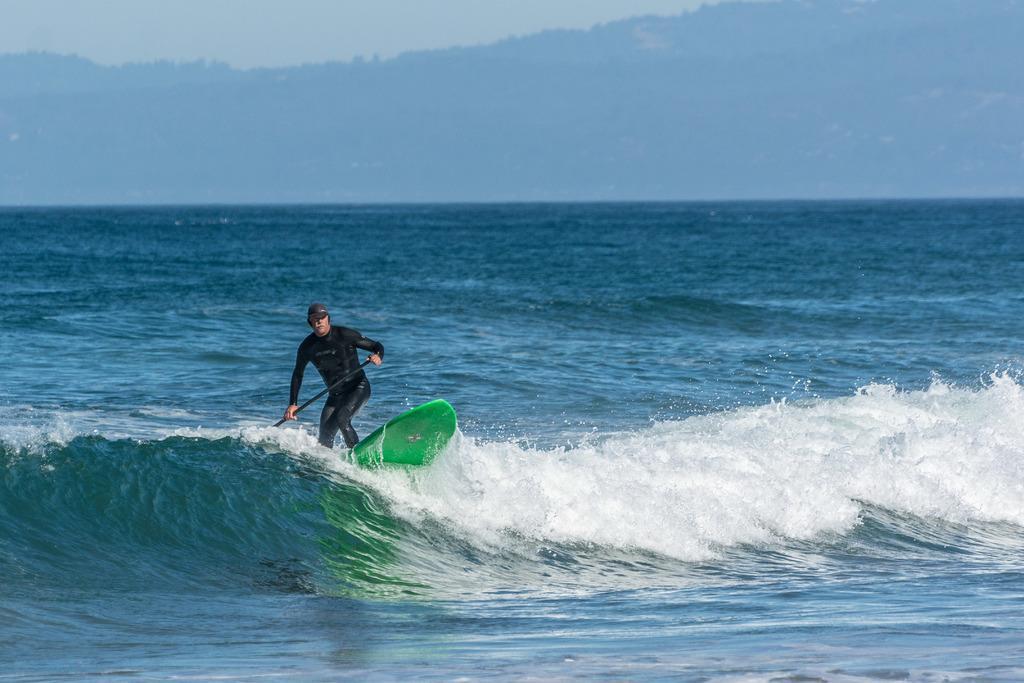Please provide a concise description of this image. In this picture I can see a man surfing with a surfboard on the water, by holding a paddle, and in the background there is a hill and the sky. 